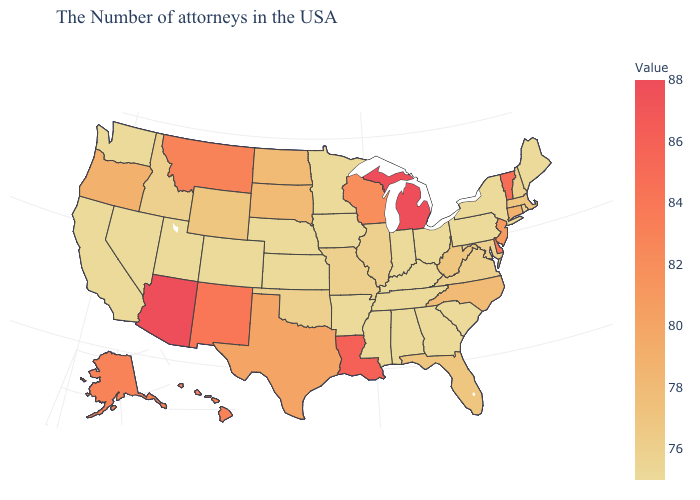Which states have the lowest value in the MidWest?
Quick response, please. Ohio, Indiana, Minnesota, Iowa, Kansas, Nebraska. Which states have the lowest value in the USA?
Concise answer only. Maine, New York, Pennsylvania, South Carolina, Ohio, Georgia, Kentucky, Indiana, Alabama, Tennessee, Mississippi, Arkansas, Minnesota, Iowa, Kansas, Nebraska, Colorado, Utah, Nevada, California, Washington. Which states have the lowest value in the USA?
Be succinct. Maine, New York, Pennsylvania, South Carolina, Ohio, Georgia, Kentucky, Indiana, Alabama, Tennessee, Mississippi, Arkansas, Minnesota, Iowa, Kansas, Nebraska, Colorado, Utah, Nevada, California, Washington. Which states have the lowest value in the USA?
Write a very short answer. Maine, New York, Pennsylvania, South Carolina, Ohio, Georgia, Kentucky, Indiana, Alabama, Tennessee, Mississippi, Arkansas, Minnesota, Iowa, Kansas, Nebraska, Colorado, Utah, Nevada, California, Washington. Is the legend a continuous bar?
Answer briefly. Yes. Does Oregon have the lowest value in the West?
Write a very short answer. No. 